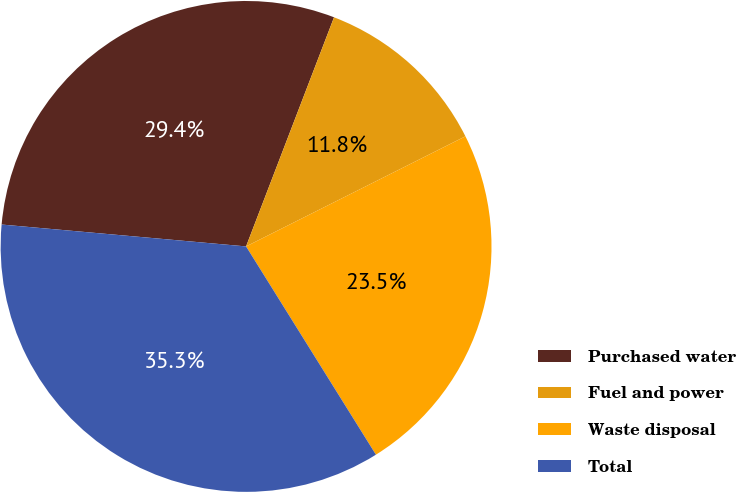Convert chart to OTSL. <chart><loc_0><loc_0><loc_500><loc_500><pie_chart><fcel>Purchased water<fcel>Fuel and power<fcel>Waste disposal<fcel>Total<nl><fcel>29.41%<fcel>11.76%<fcel>23.53%<fcel>35.29%<nl></chart> 